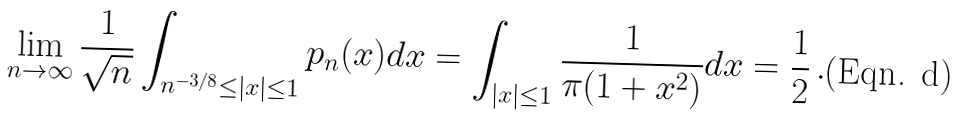<formula> <loc_0><loc_0><loc_500><loc_500>\lim _ { n \to \infty } \frac { 1 } { \sqrt { n } } \int _ { n ^ { - 3 / 8 } \leq | x | \leq 1 } p _ { n } ( x ) d x = \int _ { | x | \leq 1 } \frac { 1 } { \pi ( 1 + x ^ { 2 } ) } d x = \frac { 1 } { 2 } \, .</formula> 